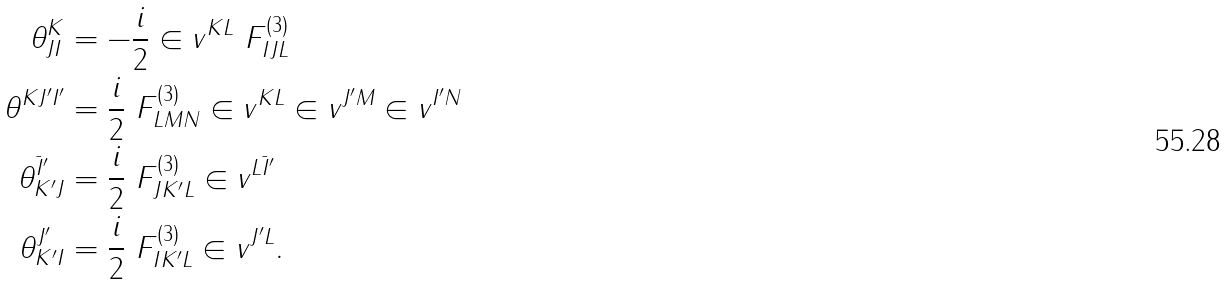<formula> <loc_0><loc_0><loc_500><loc_500>\theta ^ { K } _ { J I } & = - \frac { i } { 2 } \in v ^ { K L } \ F ^ { ( 3 ) } _ { I J L } \\ \theta ^ { K J ^ { \prime } I ^ { \prime } } & = \frac { i } { 2 } \ F ^ { ( 3 ) } _ { L M N } \in v ^ { K L } \in v ^ { J ^ { \prime } M } \in v ^ { I ^ { \prime } N } \\ \theta _ { K ^ { \prime } J } ^ { \bar { I } ^ { \prime } } & = \frac { i } { 2 } \ F ^ { ( 3 ) } _ { J K ^ { \prime } L } \in v ^ { L \bar { I } ^ { \prime } } \\ \theta _ { K ^ { \prime } I } ^ { J ^ { \prime } } & = \frac { i } { 2 } \ F ^ { ( 3 ) } _ { I K ^ { \prime } L } \in v ^ { J ^ { \prime } L } .</formula> 